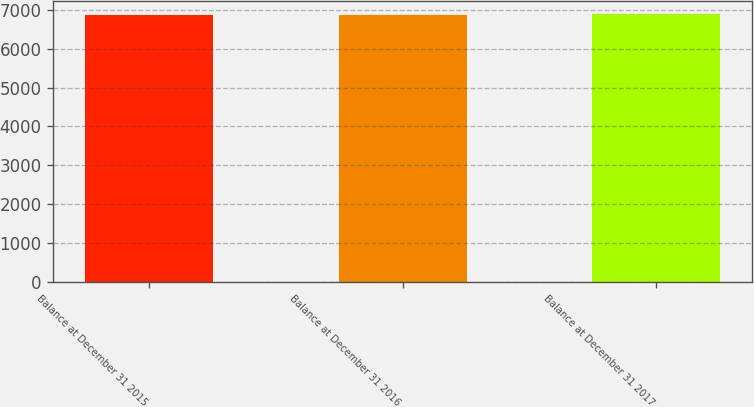Convert chart to OTSL. <chart><loc_0><loc_0><loc_500><loc_500><bar_chart><fcel>Balance at December 31 2015<fcel>Balance at December 31 2016<fcel>Balance at December 31 2017<nl><fcel>6876<fcel>6877.1<fcel>6887<nl></chart> 